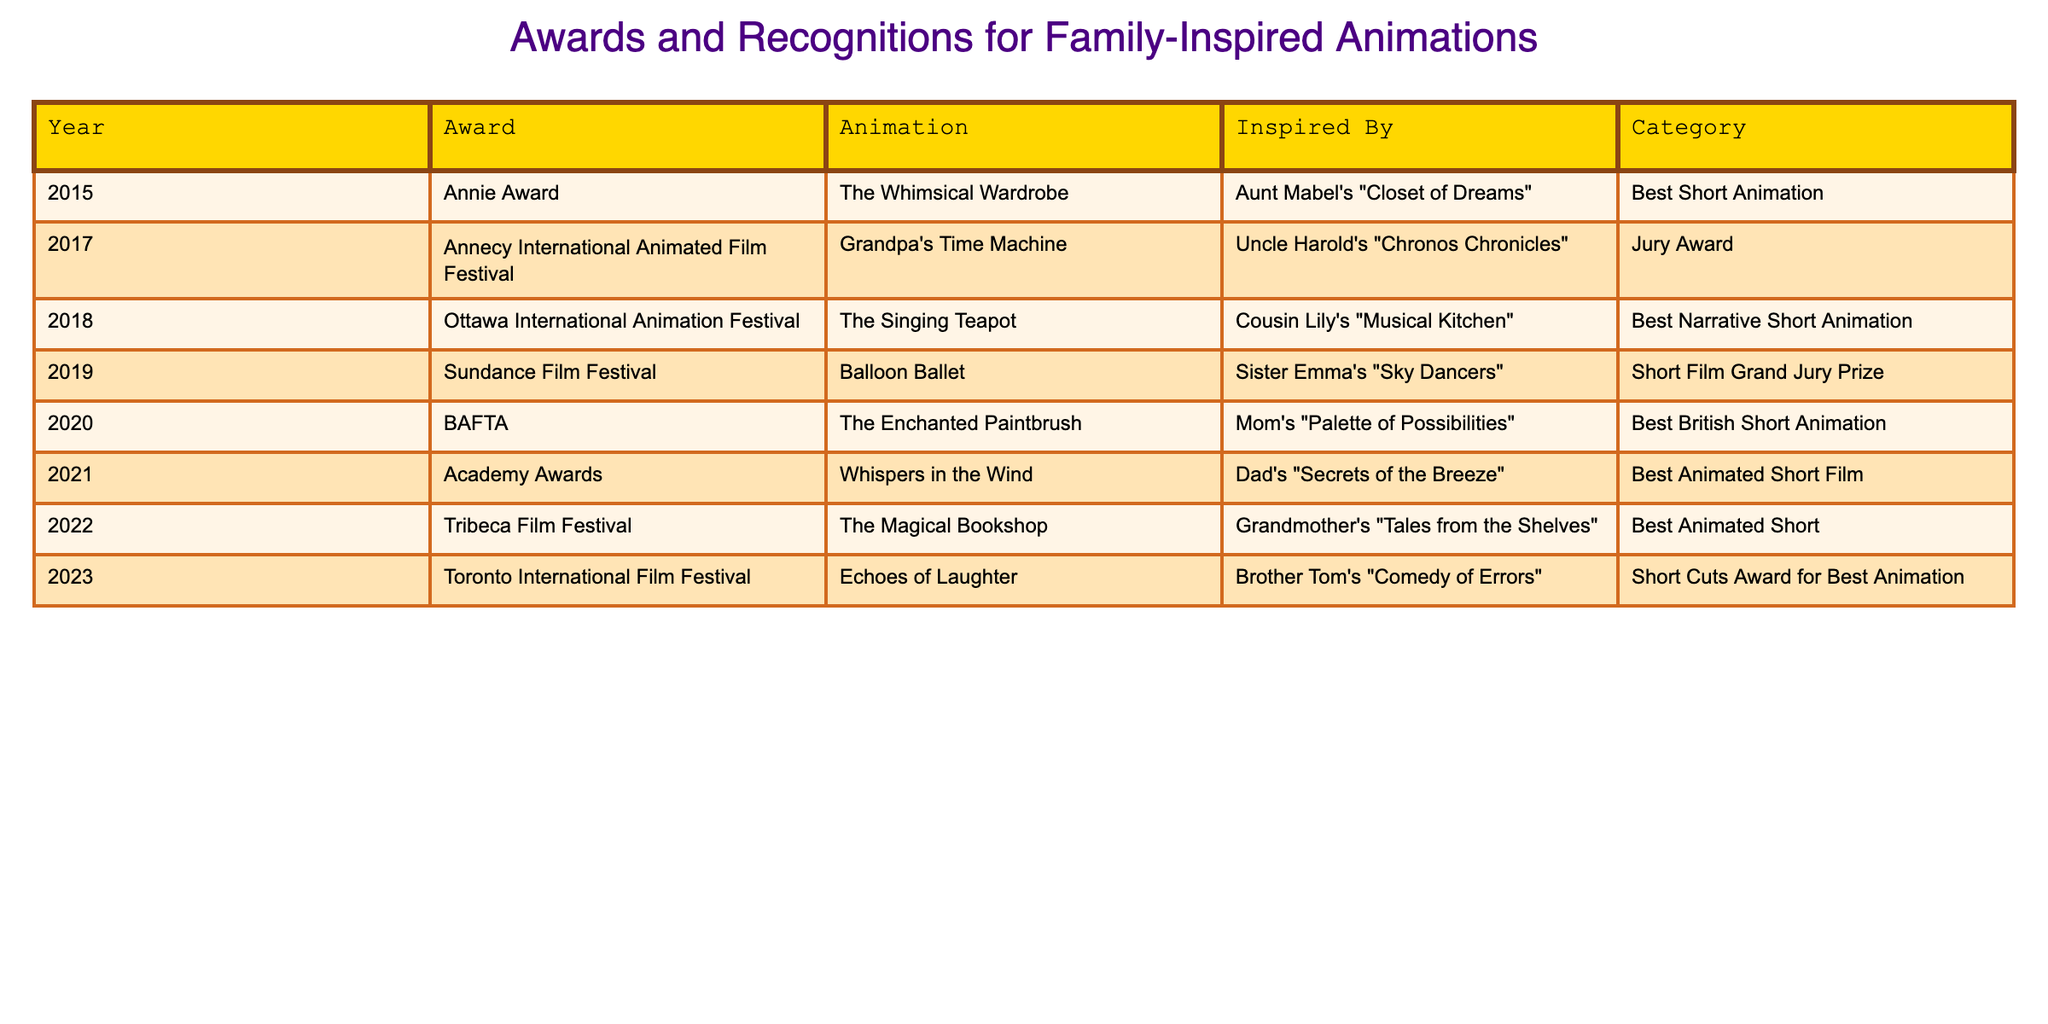What award did "The Whimsical Wardrobe" win? The table shows that "The Whimsical Wardrobe" received the Annie Award in 2015.
Answer: Annie Award Which animation inspired by Uncle Harold's play won an award? According to the table, "Grandpa's Time Machine," inspired by Uncle Harold's "Chronos Chronicles," won the Jury Award at the Annecy International Animated Film Festival in 2017.
Answer: Jury Award How many animations received awards in the year 2020? The table indicates that there was one animation that received an award in 2020, which is "The Enchanted Paintbrush."
Answer: 1 What is the most recent award listed in the table? The most recent award listed is the "Short Cuts Award for Best Animation" received by "Echoes of Laughter" in 2023.
Answer: Short Cuts Award for Best Animation Which animation won the award for Best Animated Short Film? The table shows that "Whispers in the Wind," inspired by Dad's play, won the Academy Award for Best Animated Short Film in 2021.
Answer: Whispers in the Wind How many jury awards are mentioned in the table? There are two jury awards mentioned in the table: the Jury Award for "Grandpa's Time Machine" in 2017 and the Short Film Grand Jury Prize for "Balloon Ballet" in 2019.
Answer: 2 What is the average year in which the awards were received? To find the average year, add the years (2015 + 2017 + 2018 + 2019 + 2020 + 2021 + 2022 + 2023 = 2017.875) and divide by 8. The average year is approximately 2018.
Answer: 2018 Is there an award for Best Short Animation in the table? From the data, the Annie Award for "The Whimsical Wardrobe" is categorized as Best Short Animation, confirming that such an award exists.
Answer: Yes Which animation received an award inspired by a family member's kitchen theme? The table reveals that "The Singing Teapot," inspired by Cousin Lily's "Musical Kitchen," won the award at the Ottawa International Animation Festival in 2018.
Answer: The Singing Teapot How many different family members inspired the animations that have received awards? The table lists animations inspired by eight different family members: Aunt Mabel, Uncle Harold, Cousin Lily, Sister Emma, Mom, Dad, Grandmother, and Brother Tom.
Answer: 8 